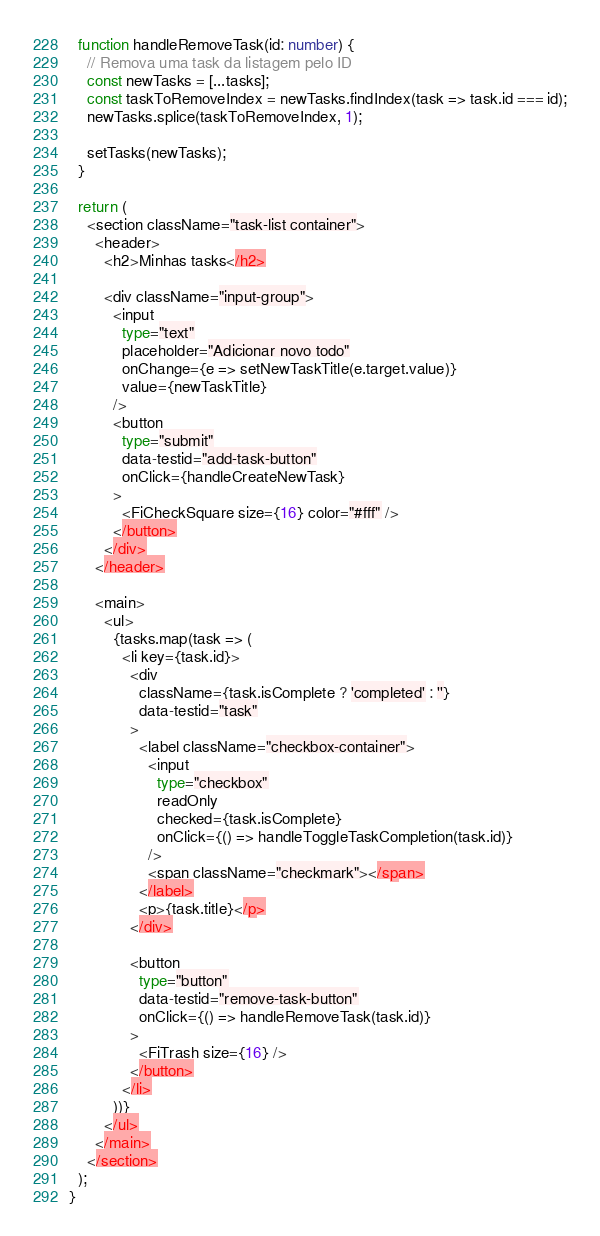<code> <loc_0><loc_0><loc_500><loc_500><_TypeScript_>  function handleRemoveTask(id: number) {
    // Remova uma task da listagem pelo ID
    const newTasks = [...tasks];
    const taskToRemoveIndex = newTasks.findIndex(task => task.id === id);
    newTasks.splice(taskToRemoveIndex, 1);

    setTasks(newTasks);
  }

  return (
    <section className="task-list container">
      <header>
        <h2>Minhas tasks</h2>

        <div className="input-group">
          <input
            type="text"
            placeholder="Adicionar novo todo"
            onChange={e => setNewTaskTitle(e.target.value)}
            value={newTaskTitle}
          />
          <button
            type="submit"
            data-testid="add-task-button"
            onClick={handleCreateNewTask}
          >
            <FiCheckSquare size={16} color="#fff" />
          </button>
        </div>
      </header>

      <main>
        <ul>
          {tasks.map(task => (
            <li key={task.id}>
              <div
                className={task.isComplete ? 'completed' : ''}
                data-testid="task"
              >
                <label className="checkbox-container">
                  <input
                    type="checkbox"
                    readOnly
                    checked={task.isComplete}
                    onClick={() => handleToggleTaskCompletion(task.id)}
                  />
                  <span className="checkmark"></span>
                </label>
                <p>{task.title}</p>
              </div>

              <button
                type="button"
                data-testid="remove-task-button"
                onClick={() => handleRemoveTask(task.id)}
              >
                <FiTrash size={16} />
              </button>
            </li>
          ))}
        </ul>
      </main>
    </section>
  );
}
</code> 